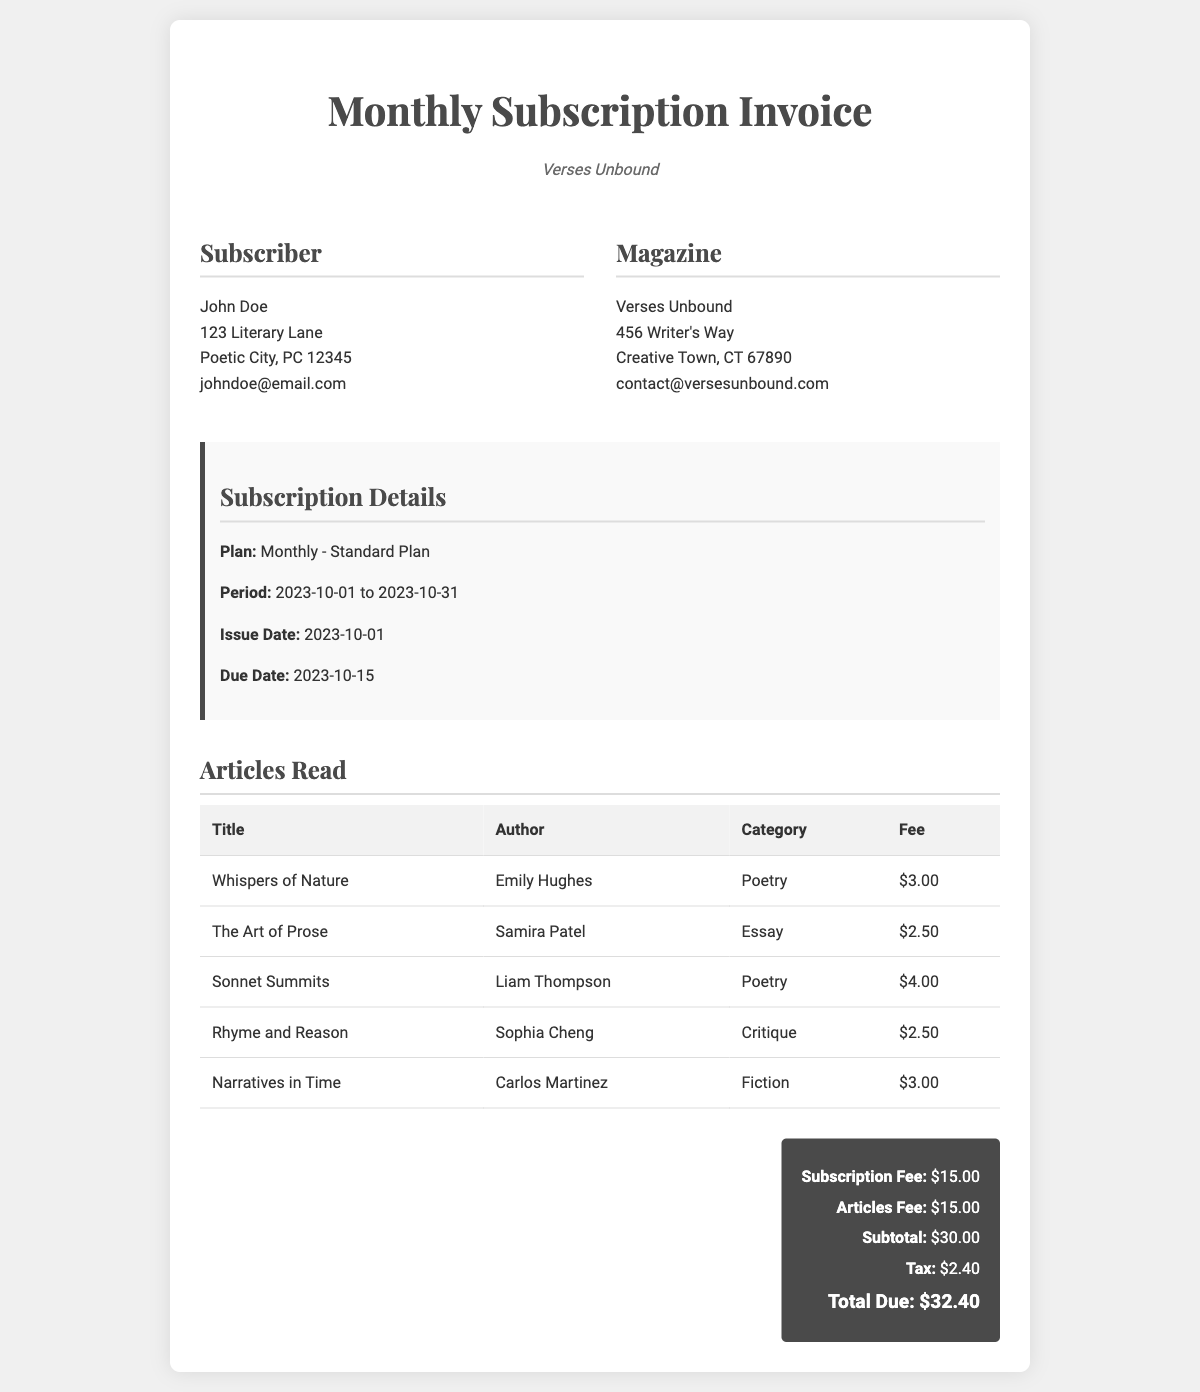What is the name of the magazine? The name of the magazine is presented in the header section of the document.
Answer: Verses Unbound Who is the subscriber? The subscriber's details are listed under the Subscriber section, identifying the individual associated with this invoice.
Answer: John Doe What is the plan type? The plan type is specified in the Subscription Details section of the document.
Answer: Monthly - Standard Plan What is the period covered by this invoice? The period is provided in the Subscription Details section, indicating the time frame for the subscription.
Answer: 2023-10-01 to 2023-10-31 How many articles did the subscriber read? The document lists the articles and their details, allowing us to count the total number included.
Answer: 5 What is the subtotal amount before tax? The subtotal is calculated before applying the tax and is summarized in the total section of the document.
Answer: $30.00 What is the total due after tax? The total due amount is presented in the total section, reflecting the invoice's final amount after tax.
Answer: $32.40 Which article has the highest fee? By comparing the fees of the listed articles, we can determine which one has the highest charge.
Answer: Sonnet Summits When is the due date for the invoice payment? The due date is clearly stated in the Subscription Details section of the document.
Answer: 2023-10-15 